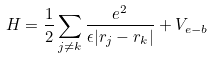<formula> <loc_0><loc_0><loc_500><loc_500>H = \frac { 1 } { 2 } \sum _ { j \neq k } \frac { e ^ { 2 } } { \epsilon | { r } _ { j } - { r } _ { k } | } + V _ { e - b }</formula> 